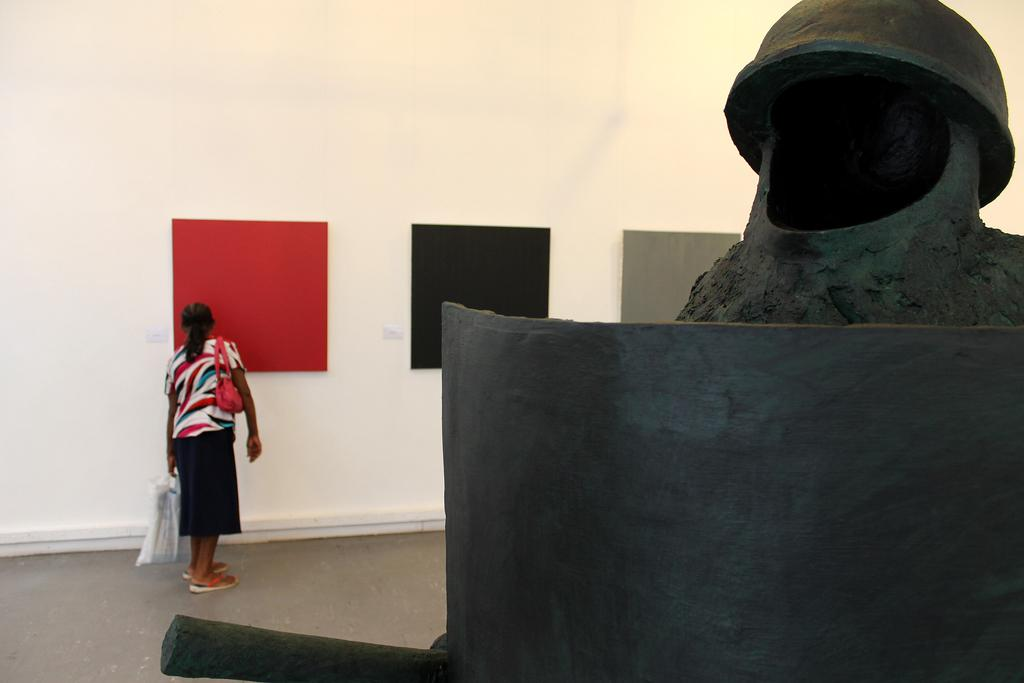What is the main subject in the image? There is a sculpture in the image. Are there any people present in the image? Yes, there is a person standing in the image. What is the person holding? The person is holding a cover. What else is the person carrying? The person is carrying a bag. What can be seen on the wall in the image? There are colorful boards on the wall in the image. What message does the person say to the visitor as they walk down the alley in the image? There is no visitor or alley present in the image, so this scenario cannot be observed. 